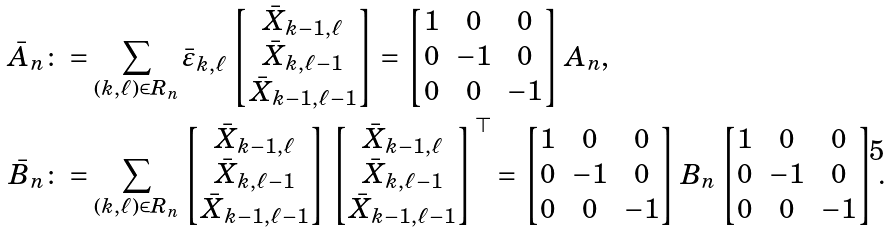<formula> <loc_0><loc_0><loc_500><loc_500>\bar { A } _ { n } & \colon = \sum _ { ( k , \ell ) \in R _ { n } } \bar { \varepsilon } _ { k , \ell } \begin{bmatrix} \bar { X } _ { k - 1 , \ell } \\ \bar { X } _ { k , \ell - 1 } \\ \bar { X } _ { k - 1 , \ell - 1 } \end{bmatrix} = \begin{bmatrix} 1 & 0 & 0 \\ 0 & - 1 & 0 \\ 0 & 0 & - 1 \end{bmatrix} A _ { n } , \\ \bar { B } _ { n } & \colon = \sum _ { ( k , \ell ) \in R _ { n } } \begin{bmatrix} \bar { X } _ { k - 1 , \ell } \\ \bar { X } _ { k , \ell - 1 } \\ \bar { X } _ { k - 1 , \ell - 1 } \end{bmatrix} \begin{bmatrix} \bar { X } _ { k - 1 , \ell } \\ \bar { X } _ { k , \ell - 1 } \\ \bar { X } _ { k - 1 , \ell - 1 } \end{bmatrix} ^ { \top } = \begin{bmatrix} 1 & 0 & 0 \\ 0 & - 1 & 0 \\ 0 & 0 & - 1 \end{bmatrix} B _ { n } \begin{bmatrix} 1 & 0 & 0 \\ 0 & - 1 & 0 \\ 0 & 0 & - 1 \end{bmatrix} .</formula> 